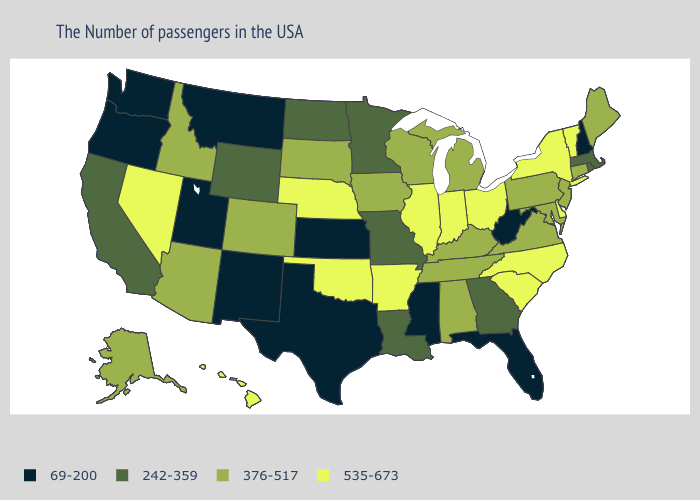Name the states that have a value in the range 376-517?
Be succinct. Maine, Connecticut, New Jersey, Maryland, Pennsylvania, Virginia, Michigan, Kentucky, Alabama, Tennessee, Wisconsin, Iowa, South Dakota, Colorado, Arizona, Idaho, Alaska. Name the states that have a value in the range 535-673?
Quick response, please. Vermont, New York, Delaware, North Carolina, South Carolina, Ohio, Indiana, Illinois, Arkansas, Nebraska, Oklahoma, Nevada, Hawaii. Is the legend a continuous bar?
Give a very brief answer. No. What is the value of Indiana?
Keep it brief. 535-673. Which states hav the highest value in the Northeast?
Quick response, please. Vermont, New York. Name the states that have a value in the range 69-200?
Be succinct. New Hampshire, West Virginia, Florida, Mississippi, Kansas, Texas, New Mexico, Utah, Montana, Washington, Oregon. Name the states that have a value in the range 376-517?
Write a very short answer. Maine, Connecticut, New Jersey, Maryland, Pennsylvania, Virginia, Michigan, Kentucky, Alabama, Tennessee, Wisconsin, Iowa, South Dakota, Colorado, Arizona, Idaho, Alaska. Which states have the lowest value in the MidWest?
Short answer required. Kansas. Among the states that border Kansas , which have the highest value?
Be succinct. Nebraska, Oklahoma. What is the highest value in states that border Virginia?
Short answer required. 535-673. What is the highest value in the USA?
Write a very short answer. 535-673. What is the highest value in the Northeast ?
Keep it brief. 535-673. Among the states that border Montana , which have the highest value?
Write a very short answer. South Dakota, Idaho. How many symbols are there in the legend?
Keep it brief. 4. Among the states that border Utah , does New Mexico have the lowest value?
Give a very brief answer. Yes. 